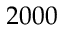<formula> <loc_0><loc_0><loc_500><loc_500>2 0 0 0</formula> 